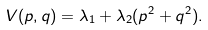Convert formula to latex. <formula><loc_0><loc_0><loc_500><loc_500>V ( p , q ) = \lambda _ { 1 } + \lambda _ { 2 } ( p ^ { 2 } + q ^ { 2 } ) .</formula> 